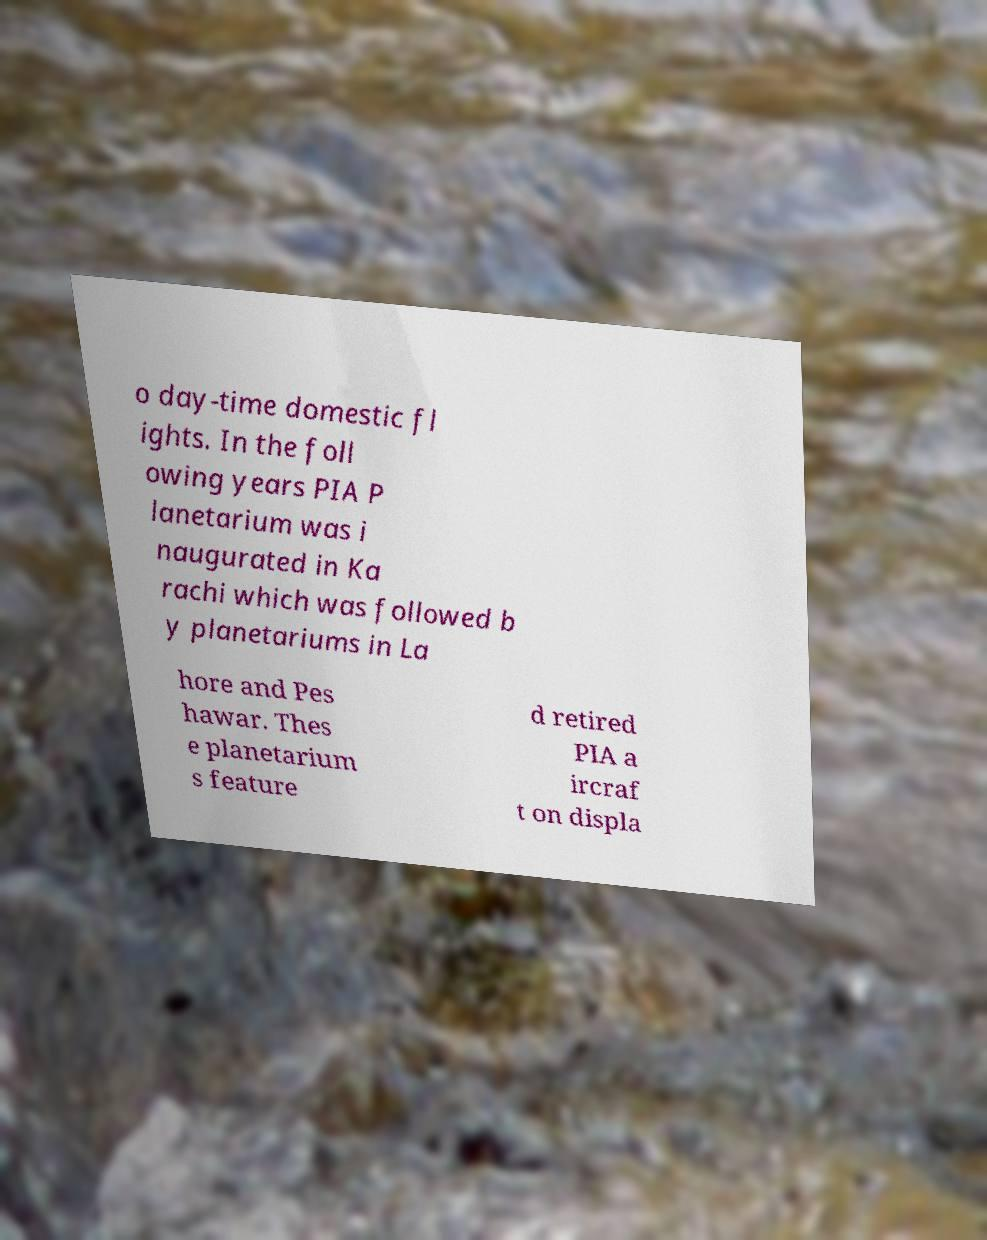I need the written content from this picture converted into text. Can you do that? o day-time domestic fl ights. In the foll owing years PIA P lanetarium was i naugurated in Ka rachi which was followed b y planetariums in La hore and Pes hawar. Thes e planetarium s feature d retired PIA a ircraf t on displa 